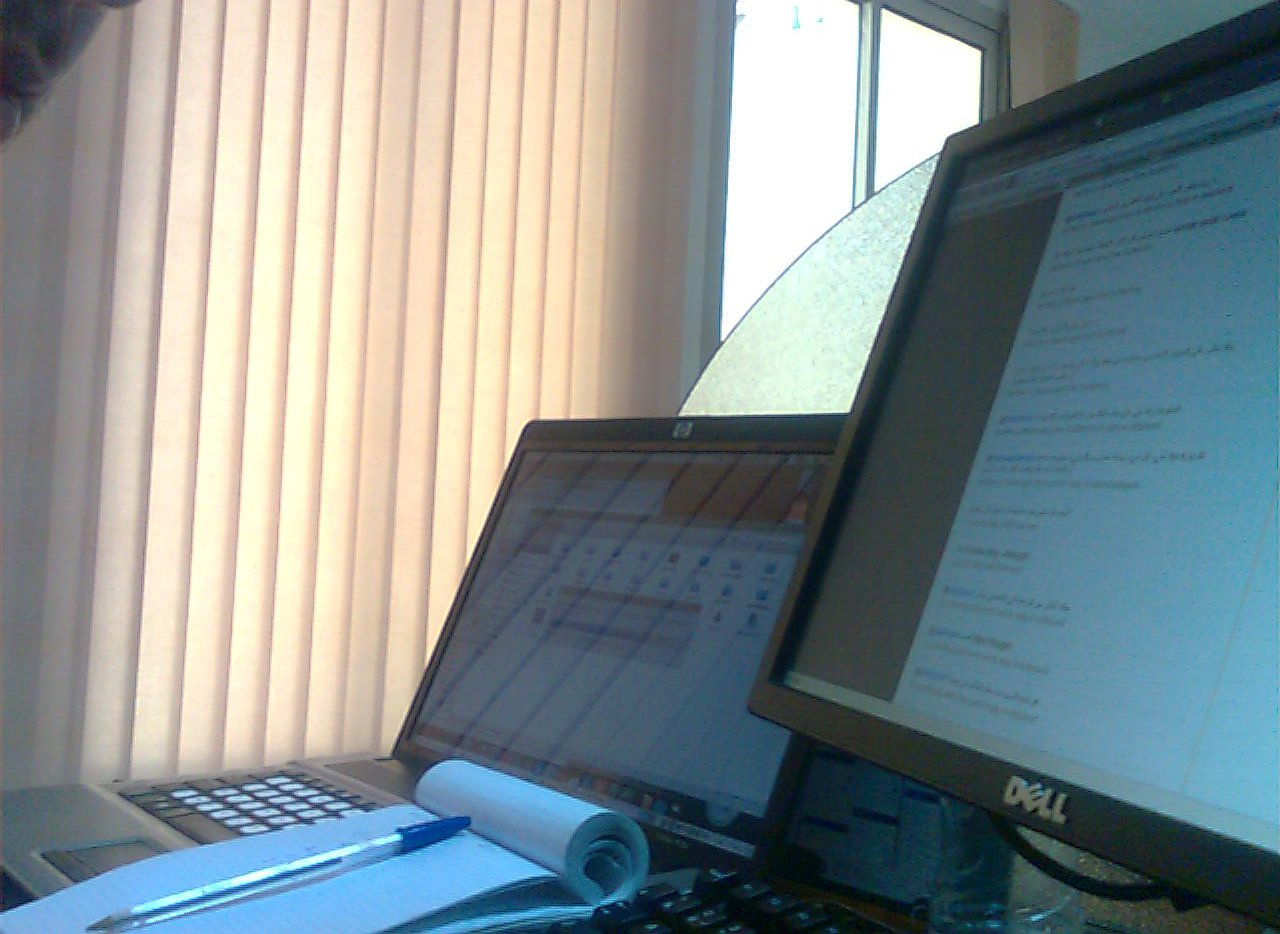Is the computer monitor on the left side or on the right? The computer monitor is positioned on the right side of the workspace. 